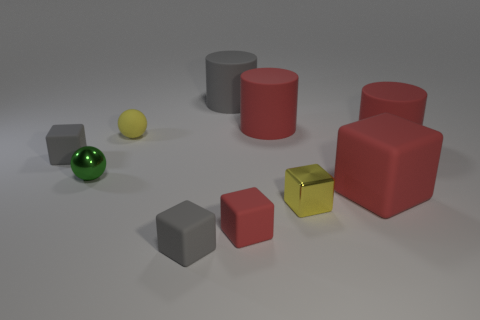Is there a large gray rubber cylinder that is in front of the tiny gray thing that is behind the shiny thing to the right of the small yellow rubber object?
Your response must be concise. No. Are there fewer large red objects left of the small yellow metallic object than tiny gray metallic balls?
Keep it short and to the point. No. How many other things are the same shape as the tiny yellow rubber object?
Your answer should be compact. 1. What number of objects are either yellow objects that are to the right of the yellow rubber ball or large cylinders that are in front of the matte ball?
Offer a very short reply. 2. There is a red rubber object that is to the left of the large red matte block and behind the metallic ball; how big is it?
Ensure brevity in your answer.  Large. There is a tiny gray rubber object that is behind the yellow metal cube; is it the same shape as the green object?
Provide a short and direct response. No. There is a yellow rubber object that is behind the small gray matte cube that is on the right side of the small gray object that is left of the green metal thing; how big is it?
Provide a succinct answer. Small. There is a matte thing that is the same color as the small metallic cube; what is its size?
Make the answer very short. Small. What number of things are tiny green metal objects or red metallic things?
Provide a short and direct response. 1. What shape is the rubber thing that is in front of the big red matte cube and on the right side of the large gray cylinder?
Provide a succinct answer. Cube. 